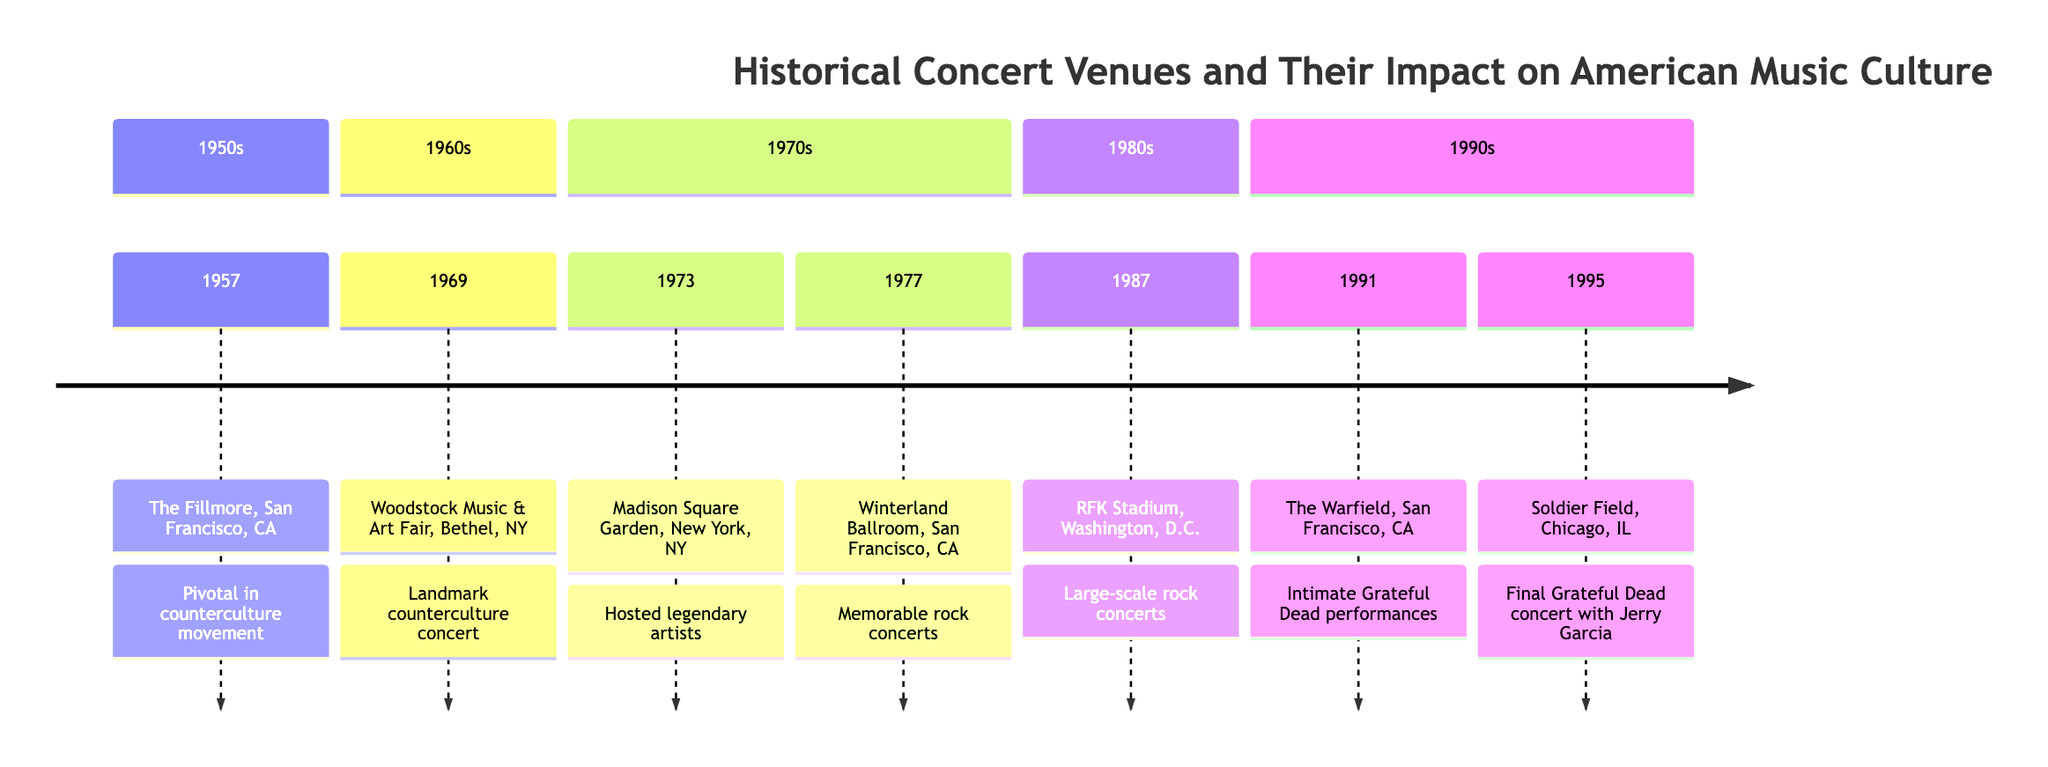What year was The Fillmore established? The diagram indicates that The Fillmore was established in the year 1957.
Answer: 1957 What venue hosted the Woodstock Music & Art Fair? According to the diagram, the Woodstock Music & Art Fair took place at Bethel, NY.
Answer: Bethel, NY How many concert venues are listed in the timeline? By counting the entries in the diagram, there are a total of seven concert venues listed.
Answer: 7 Which venue hosted The Grateful Dead's final concert with Jerry Garcia? The diagram specifies that Soldier Field in Chicago, IL, hosted The Grateful Dead's final concert with Jerry Garcia in 1995.
Answer: Soldier Field In which decade did RFK Stadium host large-scale rock concerts? The diagram shows that RFK Stadium hosted large-scale rock concerts in the 1980s.
Answer: 1980s Which two venues are located in San Francisco, CA? Referring to the diagram, the two venues located in San Francisco, CA, are The Fillmore and Winterland Ballroom.
Answer: The Fillmore, Winterland Ballroom What milestone event took place at the Woodstock Music & Art Fair in 1969? The diagram highlights that the Woodstock Music & Art Fair in 1969 was a landmark concert that epitomized the 1960s counterculture.
Answer: Landmark concert In what year did The Grateful Dead perform at Madison Square Garden? According to the timeline, The Grateful Dead performed at Madison Square Garden in 1973.
Answer: 1973 Which venue is described as hosting memorable rock concerts in 1977? The timeline notes that Winterland Ballroom hosted memorable rock concerts in 1977.
Answer: Winterland Ballroom 